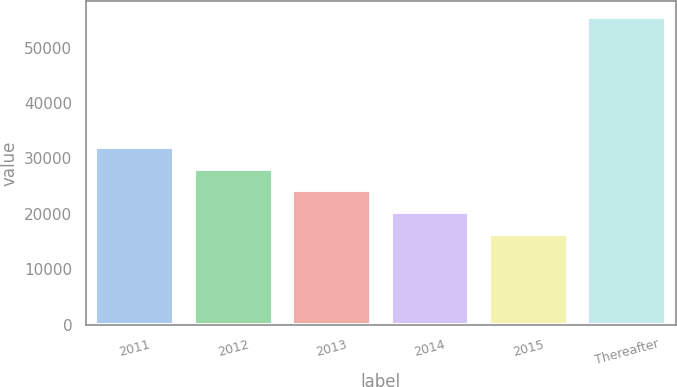Convert chart to OTSL. <chart><loc_0><loc_0><loc_500><loc_500><bar_chart><fcel>2011<fcel>2012<fcel>2013<fcel>2014<fcel>2015<fcel>Thereafter<nl><fcel>32073.6<fcel>28153.2<fcel>24232.8<fcel>20312.4<fcel>16392<fcel>55596<nl></chart> 